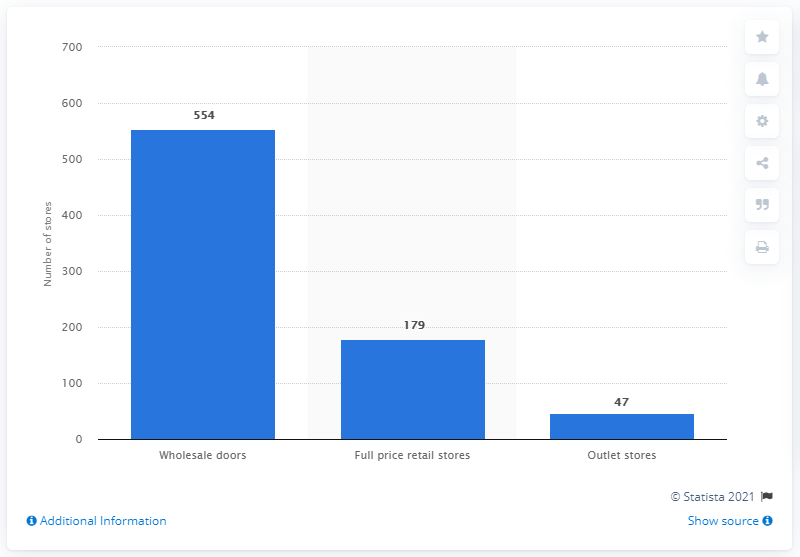Draw attention to some important aspects in this diagram. As of March 28, 2020, Capri Holdings operated a total of 179 Jimmy Choo stores. 